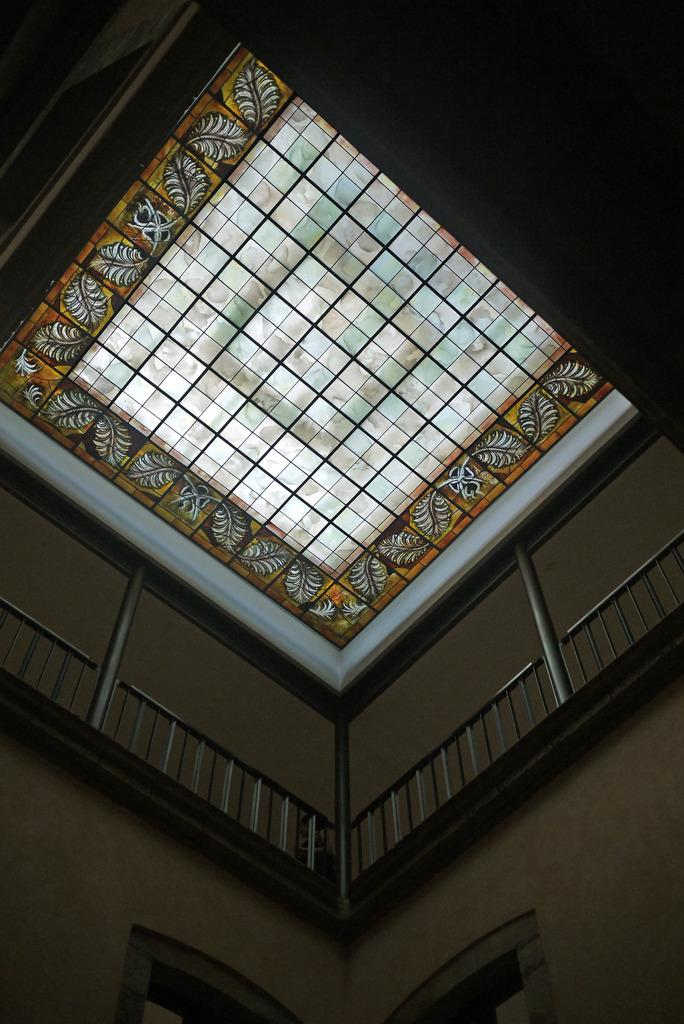What type of location is depicted in the image? The image is an inside picture of a building. What architectural feature can be seen in the image? There are railings in the image. What is another structural element present in the image? There is a wall in the image. What material is used for the top part of the image? There is a glass at the top of the image. What type of ray is emitted from the wall in the image? There is no ray emitted from the wall in the image. What type of relation is depicted between the railings and the wall in the image? The image does not depict a relation between the railings and the wall; it simply shows them as separate elements. 